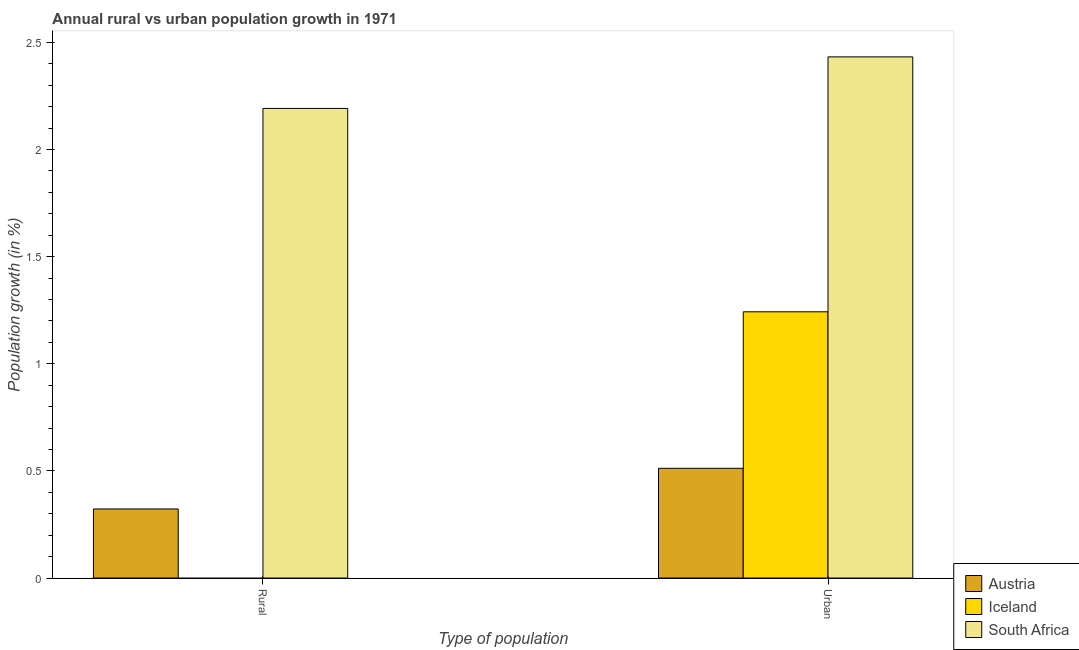How many groups of bars are there?
Your answer should be compact. 2. How many bars are there on the 1st tick from the left?
Provide a succinct answer. 2. What is the label of the 2nd group of bars from the left?
Provide a succinct answer. Urban . What is the urban population growth in Austria?
Your answer should be very brief. 0.51. Across all countries, what is the maximum rural population growth?
Offer a terse response. 2.19. Across all countries, what is the minimum urban population growth?
Your answer should be compact. 0.51. In which country was the urban population growth maximum?
Your answer should be compact. South Africa. What is the total rural population growth in the graph?
Your answer should be very brief. 2.51. What is the difference between the urban population growth in Austria and that in Iceland?
Your answer should be compact. -0.73. What is the difference between the rural population growth in Iceland and the urban population growth in South Africa?
Provide a short and direct response. -2.43. What is the average rural population growth per country?
Provide a succinct answer. 0.84. What is the difference between the rural population growth and urban population growth in South Africa?
Offer a very short reply. -0.24. What is the ratio of the rural population growth in South Africa to that in Austria?
Provide a short and direct response. 6.8. Is the urban population growth in Austria less than that in Iceland?
Provide a succinct answer. Yes. How many countries are there in the graph?
Your answer should be very brief. 3. Are the values on the major ticks of Y-axis written in scientific E-notation?
Your answer should be compact. No. Does the graph contain grids?
Provide a short and direct response. No. How are the legend labels stacked?
Your answer should be very brief. Vertical. What is the title of the graph?
Offer a terse response. Annual rural vs urban population growth in 1971. Does "Venezuela" appear as one of the legend labels in the graph?
Keep it short and to the point. No. What is the label or title of the X-axis?
Your answer should be compact. Type of population. What is the label or title of the Y-axis?
Your answer should be compact. Population growth (in %). What is the Population growth (in %) in Austria in Rural?
Give a very brief answer. 0.32. What is the Population growth (in %) in Iceland in Rural?
Provide a succinct answer. 0. What is the Population growth (in %) in South Africa in Rural?
Provide a succinct answer. 2.19. What is the Population growth (in %) of Austria in Urban ?
Offer a terse response. 0.51. What is the Population growth (in %) of Iceland in Urban ?
Keep it short and to the point. 1.24. What is the Population growth (in %) in South Africa in Urban ?
Your response must be concise. 2.43. Across all Type of population, what is the maximum Population growth (in %) of Austria?
Ensure brevity in your answer.  0.51. Across all Type of population, what is the maximum Population growth (in %) in Iceland?
Provide a short and direct response. 1.24. Across all Type of population, what is the maximum Population growth (in %) of South Africa?
Your response must be concise. 2.43. Across all Type of population, what is the minimum Population growth (in %) of Austria?
Offer a very short reply. 0.32. Across all Type of population, what is the minimum Population growth (in %) of Iceland?
Give a very brief answer. 0. Across all Type of population, what is the minimum Population growth (in %) of South Africa?
Give a very brief answer. 2.19. What is the total Population growth (in %) of Austria in the graph?
Offer a terse response. 0.83. What is the total Population growth (in %) in Iceland in the graph?
Provide a succinct answer. 1.24. What is the total Population growth (in %) of South Africa in the graph?
Provide a succinct answer. 4.62. What is the difference between the Population growth (in %) of Austria in Rural and that in Urban ?
Provide a short and direct response. -0.19. What is the difference between the Population growth (in %) of South Africa in Rural and that in Urban ?
Provide a succinct answer. -0.24. What is the difference between the Population growth (in %) of Austria in Rural and the Population growth (in %) of Iceland in Urban?
Provide a short and direct response. -0.92. What is the difference between the Population growth (in %) in Austria in Rural and the Population growth (in %) in South Africa in Urban?
Provide a succinct answer. -2.11. What is the average Population growth (in %) in Austria per Type of population?
Your response must be concise. 0.42. What is the average Population growth (in %) in Iceland per Type of population?
Provide a succinct answer. 0.62. What is the average Population growth (in %) in South Africa per Type of population?
Your answer should be compact. 2.31. What is the difference between the Population growth (in %) of Austria and Population growth (in %) of South Africa in Rural?
Keep it short and to the point. -1.87. What is the difference between the Population growth (in %) in Austria and Population growth (in %) in Iceland in Urban ?
Keep it short and to the point. -0.73. What is the difference between the Population growth (in %) of Austria and Population growth (in %) of South Africa in Urban ?
Ensure brevity in your answer.  -1.92. What is the difference between the Population growth (in %) of Iceland and Population growth (in %) of South Africa in Urban ?
Your response must be concise. -1.19. What is the ratio of the Population growth (in %) in Austria in Rural to that in Urban ?
Keep it short and to the point. 0.63. What is the ratio of the Population growth (in %) of South Africa in Rural to that in Urban ?
Make the answer very short. 0.9. What is the difference between the highest and the second highest Population growth (in %) of Austria?
Offer a very short reply. 0.19. What is the difference between the highest and the second highest Population growth (in %) in South Africa?
Your response must be concise. 0.24. What is the difference between the highest and the lowest Population growth (in %) in Austria?
Make the answer very short. 0.19. What is the difference between the highest and the lowest Population growth (in %) of Iceland?
Your answer should be very brief. 1.24. What is the difference between the highest and the lowest Population growth (in %) of South Africa?
Provide a succinct answer. 0.24. 